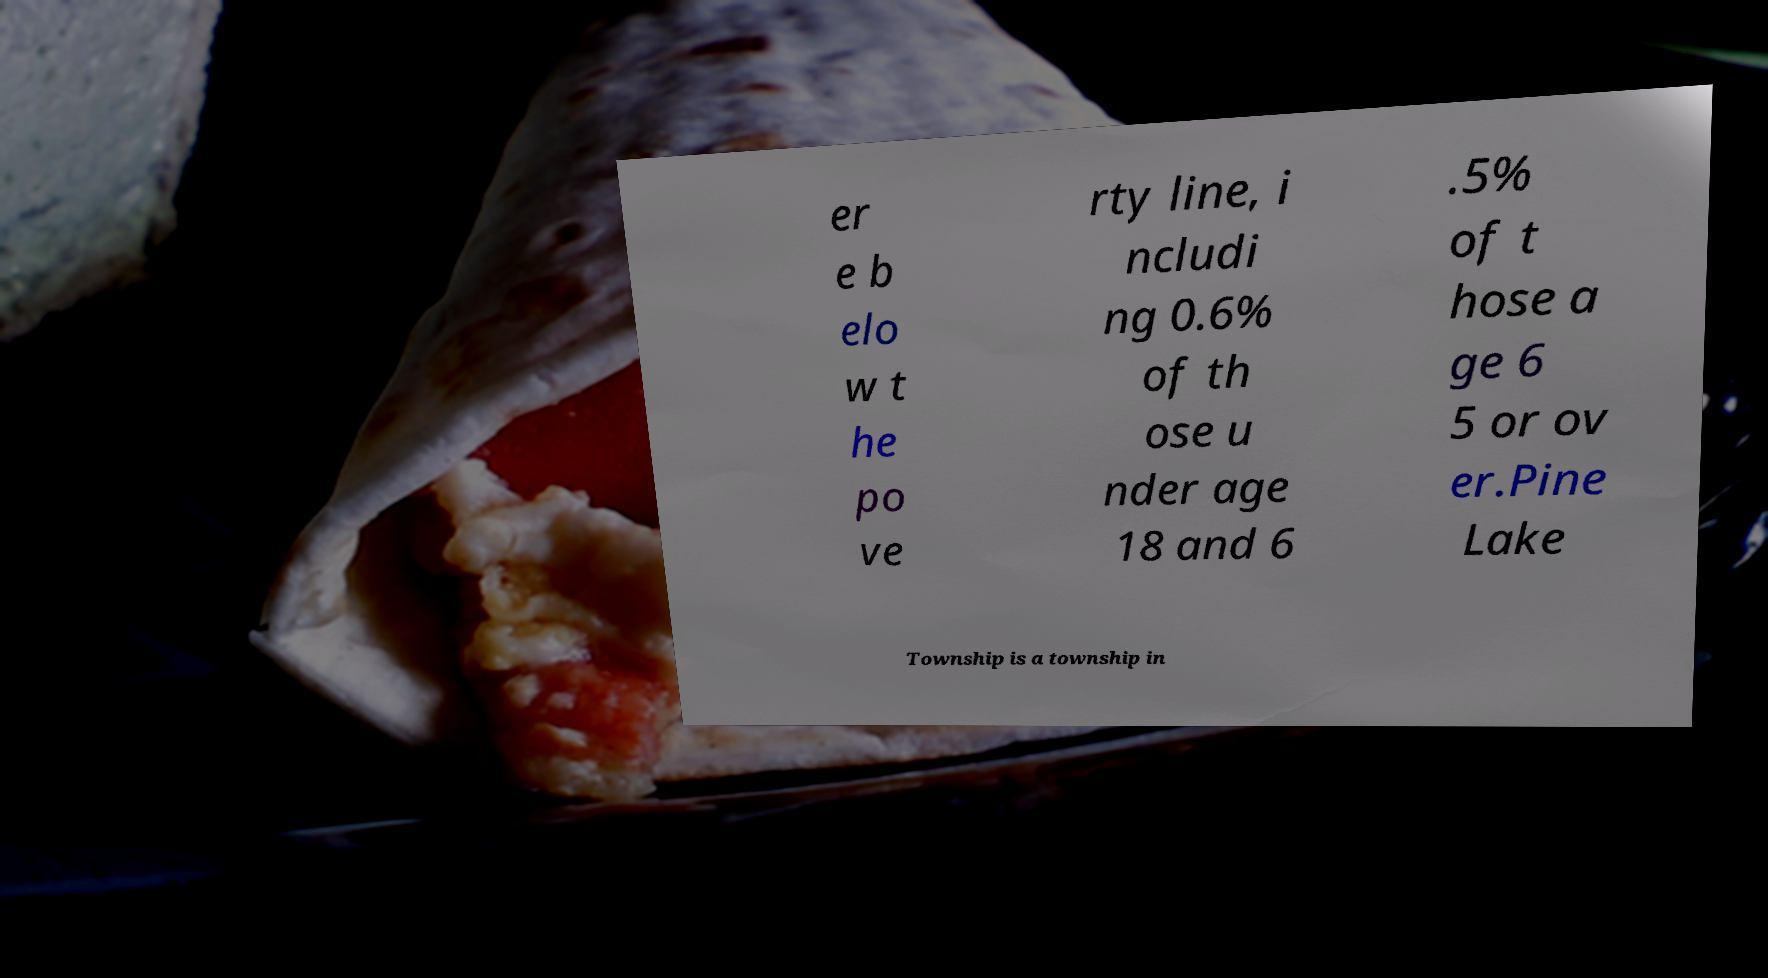For documentation purposes, I need the text within this image transcribed. Could you provide that? er e b elo w t he po ve rty line, i ncludi ng 0.6% of th ose u nder age 18 and 6 .5% of t hose a ge 6 5 or ov er.Pine Lake Township is a township in 